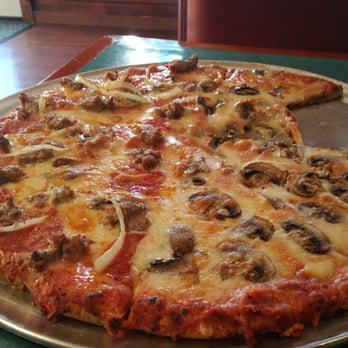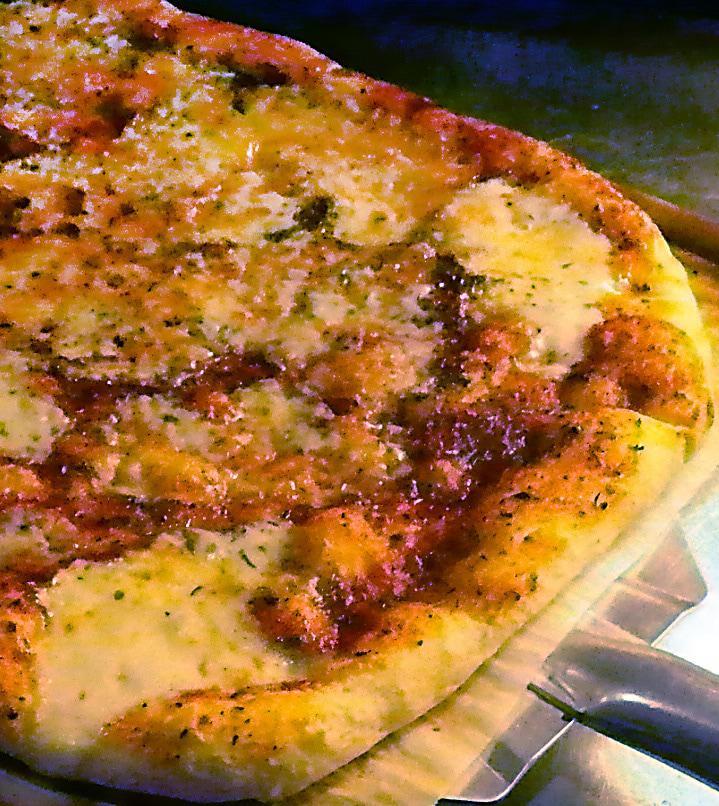The first image is the image on the left, the second image is the image on the right. Considering the images on both sides, is "The left pizza has something green on it." valid? Answer yes or no. No. The first image is the image on the left, the second image is the image on the right. Assess this claim about the two images: "There are two pizza that are perfect circles.". Correct or not? Answer yes or no. No. 